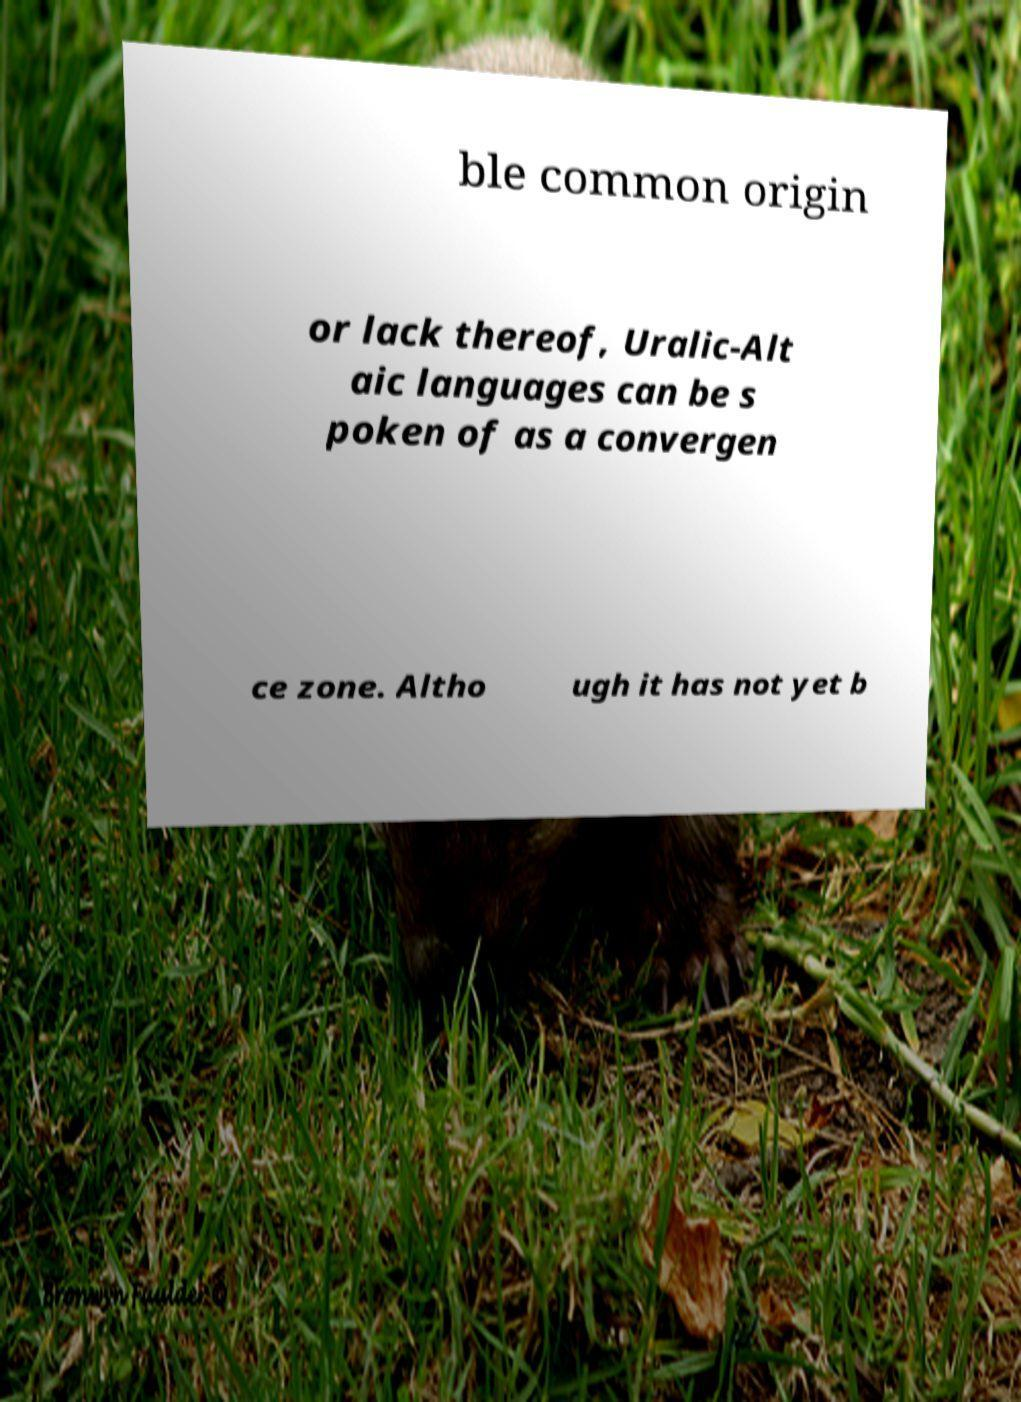Can you accurately transcribe the text from the provided image for me? ble common origin or lack thereof, Uralic-Alt aic languages can be s poken of as a convergen ce zone. Altho ugh it has not yet b 